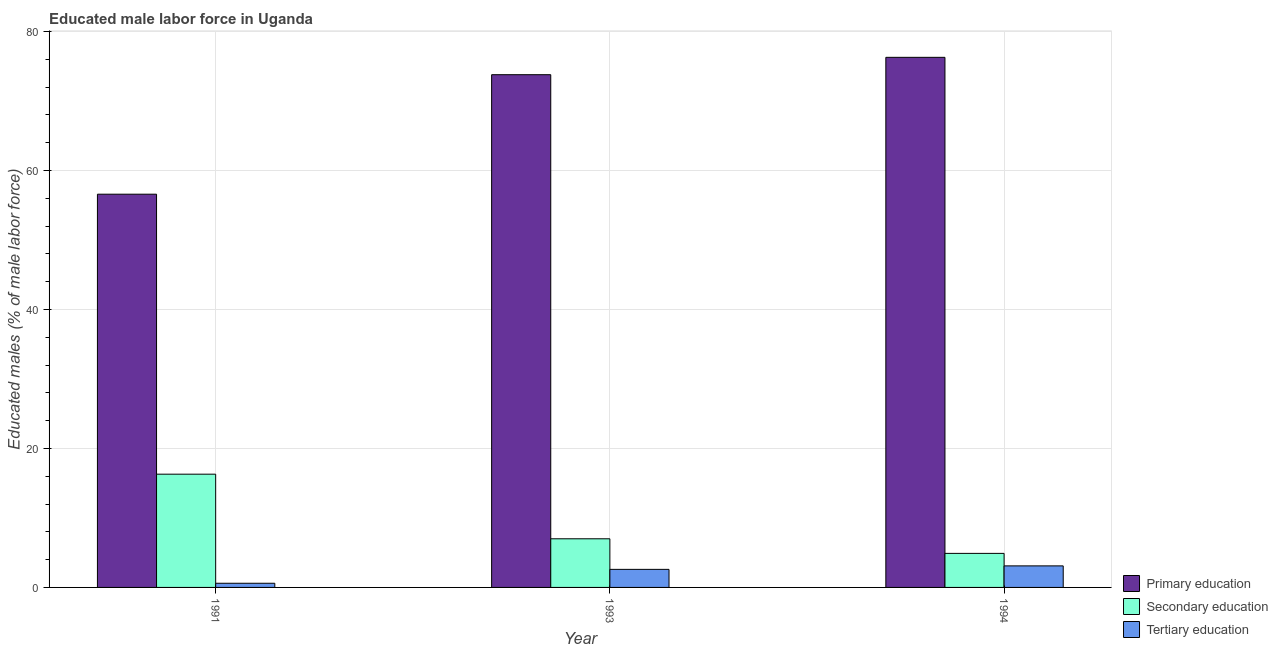How many different coloured bars are there?
Your response must be concise. 3. How many groups of bars are there?
Your answer should be very brief. 3. Are the number of bars per tick equal to the number of legend labels?
Provide a short and direct response. Yes. How many bars are there on the 3rd tick from the right?
Your response must be concise. 3. What is the label of the 3rd group of bars from the left?
Offer a very short reply. 1994. In how many cases, is the number of bars for a given year not equal to the number of legend labels?
Offer a very short reply. 0. What is the percentage of male labor force who received primary education in 1993?
Keep it short and to the point. 73.8. Across all years, what is the maximum percentage of male labor force who received tertiary education?
Provide a short and direct response. 3.1. Across all years, what is the minimum percentage of male labor force who received primary education?
Make the answer very short. 56.6. What is the total percentage of male labor force who received primary education in the graph?
Ensure brevity in your answer.  206.7. What is the difference between the percentage of male labor force who received tertiary education in 1991 and that in 1993?
Give a very brief answer. -2. What is the difference between the percentage of male labor force who received secondary education in 1993 and the percentage of male labor force who received tertiary education in 1994?
Make the answer very short. 2.1. What is the average percentage of male labor force who received tertiary education per year?
Provide a short and direct response. 2.1. What is the ratio of the percentage of male labor force who received secondary education in 1991 to that in 1993?
Provide a short and direct response. 2.33. What is the difference between the highest and the lowest percentage of male labor force who received primary education?
Your answer should be compact. 19.7. In how many years, is the percentage of male labor force who received primary education greater than the average percentage of male labor force who received primary education taken over all years?
Give a very brief answer. 2. What does the 2nd bar from the left in 1993 represents?
Provide a succinct answer. Secondary education. What does the 2nd bar from the right in 1991 represents?
Provide a short and direct response. Secondary education. Is it the case that in every year, the sum of the percentage of male labor force who received primary education and percentage of male labor force who received secondary education is greater than the percentage of male labor force who received tertiary education?
Offer a very short reply. Yes. How many bars are there?
Make the answer very short. 9. What is the difference between two consecutive major ticks on the Y-axis?
Your answer should be very brief. 20. Are the values on the major ticks of Y-axis written in scientific E-notation?
Your response must be concise. No. Does the graph contain any zero values?
Keep it short and to the point. No. How many legend labels are there?
Provide a succinct answer. 3. How are the legend labels stacked?
Provide a succinct answer. Vertical. What is the title of the graph?
Provide a short and direct response. Educated male labor force in Uganda. What is the label or title of the Y-axis?
Offer a very short reply. Educated males (% of male labor force). What is the Educated males (% of male labor force) in Primary education in 1991?
Make the answer very short. 56.6. What is the Educated males (% of male labor force) of Secondary education in 1991?
Offer a terse response. 16.3. What is the Educated males (% of male labor force) of Tertiary education in 1991?
Your answer should be very brief. 0.6. What is the Educated males (% of male labor force) in Primary education in 1993?
Your answer should be very brief. 73.8. What is the Educated males (% of male labor force) of Tertiary education in 1993?
Keep it short and to the point. 2.6. What is the Educated males (% of male labor force) of Primary education in 1994?
Make the answer very short. 76.3. What is the Educated males (% of male labor force) in Secondary education in 1994?
Your answer should be very brief. 4.9. What is the Educated males (% of male labor force) of Tertiary education in 1994?
Provide a succinct answer. 3.1. Across all years, what is the maximum Educated males (% of male labor force) of Primary education?
Your answer should be compact. 76.3. Across all years, what is the maximum Educated males (% of male labor force) in Secondary education?
Ensure brevity in your answer.  16.3. Across all years, what is the maximum Educated males (% of male labor force) in Tertiary education?
Your answer should be compact. 3.1. Across all years, what is the minimum Educated males (% of male labor force) in Primary education?
Offer a very short reply. 56.6. Across all years, what is the minimum Educated males (% of male labor force) of Secondary education?
Keep it short and to the point. 4.9. Across all years, what is the minimum Educated males (% of male labor force) of Tertiary education?
Give a very brief answer. 0.6. What is the total Educated males (% of male labor force) of Primary education in the graph?
Your answer should be compact. 206.7. What is the total Educated males (% of male labor force) in Secondary education in the graph?
Provide a short and direct response. 28.2. What is the difference between the Educated males (% of male labor force) of Primary education in 1991 and that in 1993?
Give a very brief answer. -17.2. What is the difference between the Educated males (% of male labor force) of Tertiary education in 1991 and that in 1993?
Your response must be concise. -2. What is the difference between the Educated males (% of male labor force) of Primary education in 1991 and that in 1994?
Ensure brevity in your answer.  -19.7. What is the difference between the Educated males (% of male labor force) of Secondary education in 1993 and that in 1994?
Offer a very short reply. 2.1. What is the difference between the Educated males (% of male labor force) of Tertiary education in 1993 and that in 1994?
Keep it short and to the point. -0.5. What is the difference between the Educated males (% of male labor force) of Primary education in 1991 and the Educated males (% of male labor force) of Secondary education in 1993?
Ensure brevity in your answer.  49.6. What is the difference between the Educated males (% of male labor force) of Primary education in 1991 and the Educated males (% of male labor force) of Tertiary education in 1993?
Your answer should be very brief. 54. What is the difference between the Educated males (% of male labor force) in Primary education in 1991 and the Educated males (% of male labor force) in Secondary education in 1994?
Your response must be concise. 51.7. What is the difference between the Educated males (% of male labor force) of Primary education in 1991 and the Educated males (% of male labor force) of Tertiary education in 1994?
Offer a terse response. 53.5. What is the difference between the Educated males (% of male labor force) in Secondary education in 1991 and the Educated males (% of male labor force) in Tertiary education in 1994?
Give a very brief answer. 13.2. What is the difference between the Educated males (% of male labor force) in Primary education in 1993 and the Educated males (% of male labor force) in Secondary education in 1994?
Offer a terse response. 68.9. What is the difference between the Educated males (% of male labor force) in Primary education in 1993 and the Educated males (% of male labor force) in Tertiary education in 1994?
Provide a short and direct response. 70.7. What is the average Educated males (% of male labor force) in Primary education per year?
Make the answer very short. 68.9. What is the average Educated males (% of male labor force) in Secondary education per year?
Your answer should be compact. 9.4. In the year 1991, what is the difference between the Educated males (% of male labor force) of Primary education and Educated males (% of male labor force) of Secondary education?
Provide a succinct answer. 40.3. In the year 1991, what is the difference between the Educated males (% of male labor force) in Secondary education and Educated males (% of male labor force) in Tertiary education?
Provide a succinct answer. 15.7. In the year 1993, what is the difference between the Educated males (% of male labor force) in Primary education and Educated males (% of male labor force) in Secondary education?
Provide a succinct answer. 66.8. In the year 1993, what is the difference between the Educated males (% of male labor force) of Primary education and Educated males (% of male labor force) of Tertiary education?
Your answer should be compact. 71.2. In the year 1993, what is the difference between the Educated males (% of male labor force) in Secondary education and Educated males (% of male labor force) in Tertiary education?
Provide a succinct answer. 4.4. In the year 1994, what is the difference between the Educated males (% of male labor force) in Primary education and Educated males (% of male labor force) in Secondary education?
Ensure brevity in your answer.  71.4. In the year 1994, what is the difference between the Educated males (% of male labor force) of Primary education and Educated males (% of male labor force) of Tertiary education?
Provide a succinct answer. 73.2. What is the ratio of the Educated males (% of male labor force) of Primary education in 1991 to that in 1993?
Give a very brief answer. 0.77. What is the ratio of the Educated males (% of male labor force) of Secondary education in 1991 to that in 1993?
Your answer should be very brief. 2.33. What is the ratio of the Educated males (% of male labor force) of Tertiary education in 1991 to that in 1993?
Offer a very short reply. 0.23. What is the ratio of the Educated males (% of male labor force) in Primary education in 1991 to that in 1994?
Provide a short and direct response. 0.74. What is the ratio of the Educated males (% of male labor force) of Secondary education in 1991 to that in 1994?
Offer a terse response. 3.33. What is the ratio of the Educated males (% of male labor force) of Tertiary education in 1991 to that in 1994?
Provide a short and direct response. 0.19. What is the ratio of the Educated males (% of male labor force) of Primary education in 1993 to that in 1994?
Your answer should be compact. 0.97. What is the ratio of the Educated males (% of male labor force) of Secondary education in 1993 to that in 1994?
Provide a short and direct response. 1.43. What is the ratio of the Educated males (% of male labor force) of Tertiary education in 1993 to that in 1994?
Provide a succinct answer. 0.84. What is the difference between the highest and the second highest Educated males (% of male labor force) in Tertiary education?
Ensure brevity in your answer.  0.5. What is the difference between the highest and the lowest Educated males (% of male labor force) of Primary education?
Make the answer very short. 19.7. What is the difference between the highest and the lowest Educated males (% of male labor force) in Secondary education?
Provide a succinct answer. 11.4. 